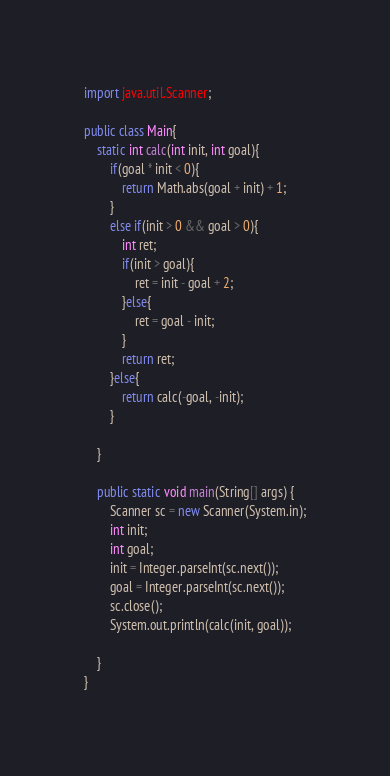<code> <loc_0><loc_0><loc_500><loc_500><_Java_>import java.util.Scanner;

public class Main{
    static int calc(int init, int goal){
        if(goal * init < 0){
            return Math.abs(goal + init) + 1;
        }
        else if(init > 0 && goal > 0){
            int ret;
            if(init > goal){
                ret = init - goal + 2;
            }else{
                ret = goal - init;
            }
            return ret;
        }else{
            return calc(-goal, -init);
        }
            
    }

    public static void main(String[] args) {
        Scanner sc = new Scanner(System.in);
        int init;
        int goal;
        init = Integer.parseInt(sc.next());
        goal = Integer.parseInt(sc.next());
        sc.close();
        System.out.println(calc(init, goal));
        
    }
}</code> 